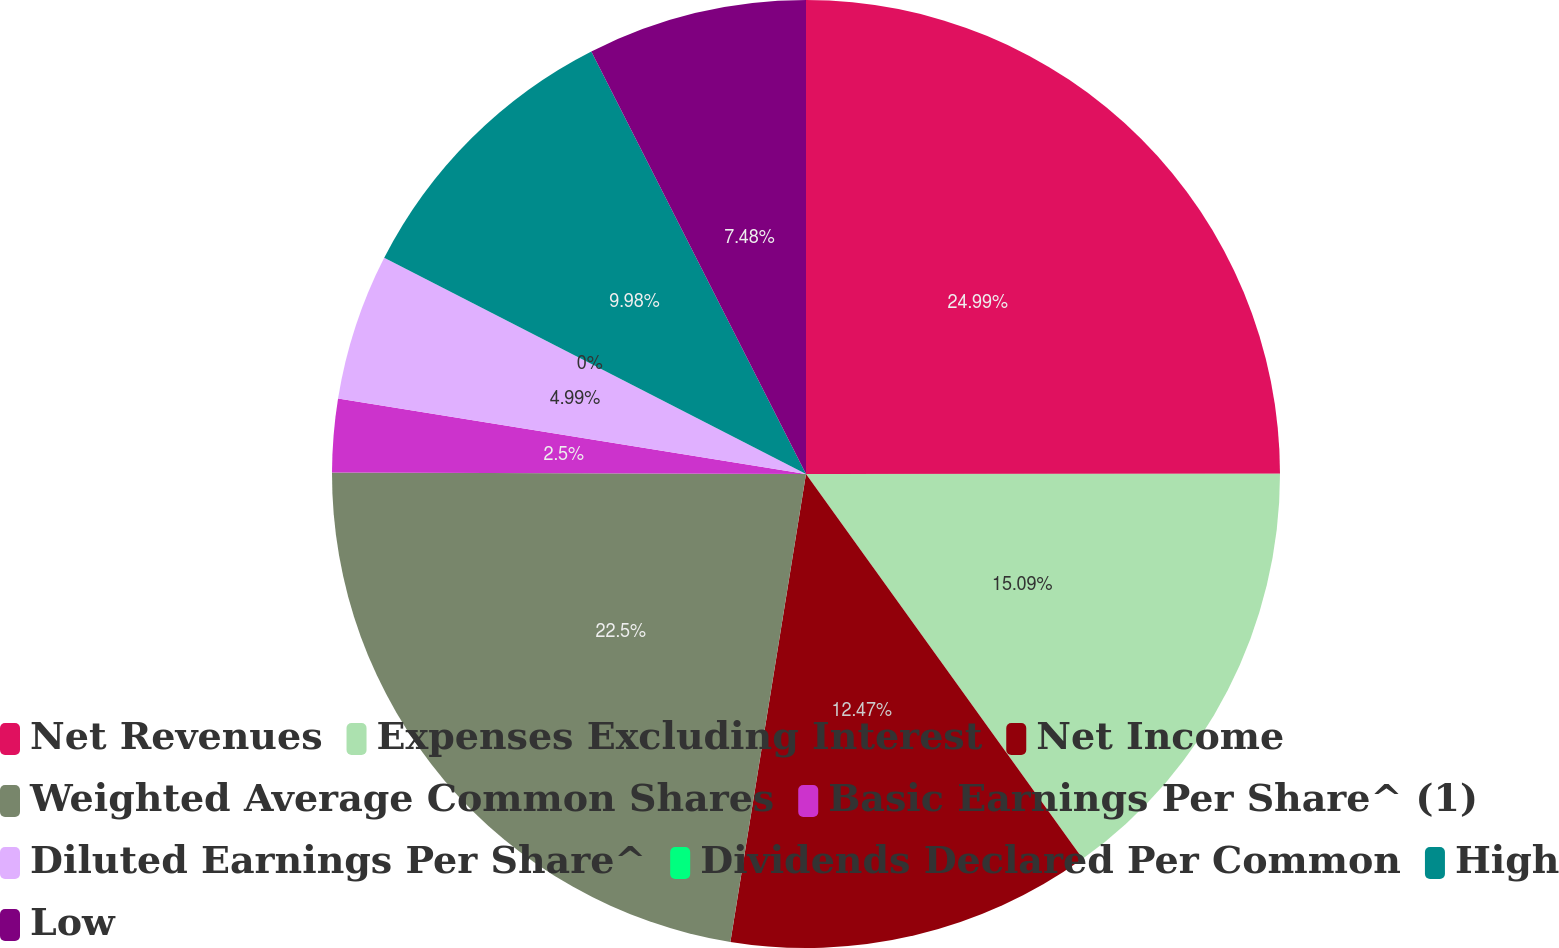Convert chart to OTSL. <chart><loc_0><loc_0><loc_500><loc_500><pie_chart><fcel>Net Revenues<fcel>Expenses Excluding Interest<fcel>Net Income<fcel>Weighted Average Common Shares<fcel>Basic Earnings Per Share^ (1)<fcel>Diluted Earnings Per Share^<fcel>Dividends Declared Per Common<fcel>High<fcel>Low<nl><fcel>24.99%<fcel>15.09%<fcel>12.47%<fcel>22.5%<fcel>2.5%<fcel>4.99%<fcel>0.0%<fcel>9.98%<fcel>7.48%<nl></chart> 